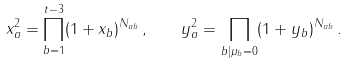<formula> <loc_0><loc_0><loc_500><loc_500>x _ { a } ^ { 2 } = \prod _ { b = 1 } ^ { t - 3 } ( 1 + x _ { b } ) ^ { N _ { a b } } \, , \quad y _ { a } ^ { 2 } = \prod _ { b | \mu _ { b } = 0 } ( 1 + y _ { b } ) ^ { N _ { a b } } \, .</formula> 